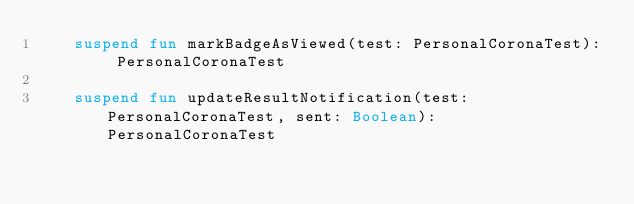<code> <loc_0><loc_0><loc_500><loc_500><_Kotlin_>    suspend fun markBadgeAsViewed(test: PersonalCoronaTest): PersonalCoronaTest

    suspend fun updateResultNotification(test: PersonalCoronaTest, sent: Boolean): PersonalCoronaTest
</code> 